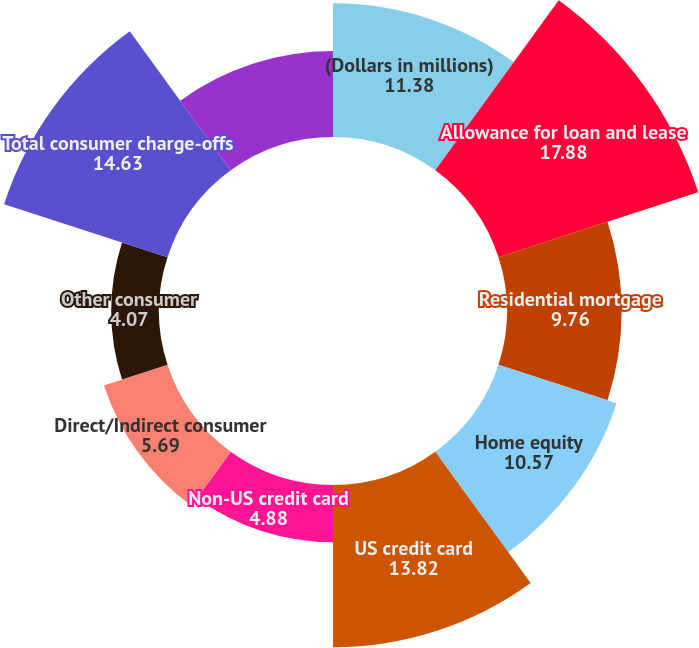Convert chart to OTSL. <chart><loc_0><loc_0><loc_500><loc_500><pie_chart><fcel>(Dollars in millions)<fcel>Allowance for loan and lease<fcel>Residential mortgage<fcel>Home equity<fcel>US credit card<fcel>Non-US credit card<fcel>Direct/Indirect consumer<fcel>Other consumer<fcel>Total consumer charge-offs<fcel>US commercial (1)<nl><fcel>11.38%<fcel>17.88%<fcel>9.76%<fcel>10.57%<fcel>13.82%<fcel>4.88%<fcel>5.69%<fcel>4.07%<fcel>14.63%<fcel>7.32%<nl></chart> 